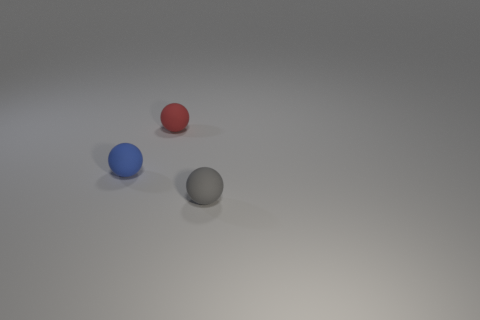What number of objects are tiny red objects or brown blocks?
Make the answer very short. 1. The red ball is what size?
Ensure brevity in your answer.  Small. Is the number of blue balls less than the number of big green metallic blocks?
Your response must be concise. No. There is a object that is behind the tiny blue sphere; what is its shape?
Offer a very short reply. Sphere. There is a matte ball that is in front of the blue rubber sphere; are there any red things left of it?
Provide a succinct answer. Yes. What number of tiny blue balls have the same material as the gray sphere?
Provide a succinct answer. 1. There is a rubber ball that is on the right side of the matte object behind the tiny object that is left of the red thing; what size is it?
Provide a succinct answer. Small. How many rubber things are in front of the blue rubber sphere?
Offer a terse response. 1. Are there more big red metallic balls than blue spheres?
Your answer should be compact. No. There is a matte ball that is both in front of the red thing and to the right of the blue matte sphere; how big is it?
Give a very brief answer. Small. 